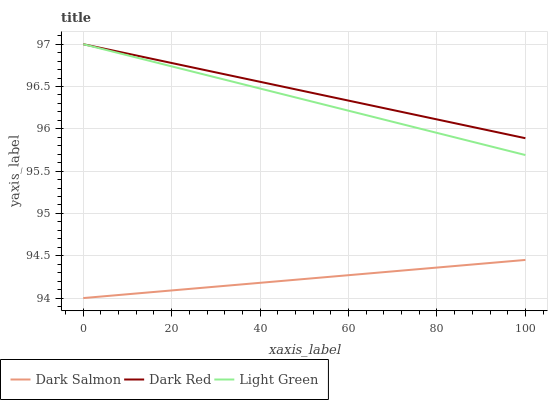Does Light Green have the minimum area under the curve?
Answer yes or no. No. Does Light Green have the maximum area under the curve?
Answer yes or no. No. Is Dark Salmon the smoothest?
Answer yes or no. No. Is Dark Salmon the roughest?
Answer yes or no. No. Does Light Green have the lowest value?
Answer yes or no. No. Does Dark Salmon have the highest value?
Answer yes or no. No. Is Dark Salmon less than Light Green?
Answer yes or no. Yes. Is Dark Red greater than Dark Salmon?
Answer yes or no. Yes. Does Dark Salmon intersect Light Green?
Answer yes or no. No. 